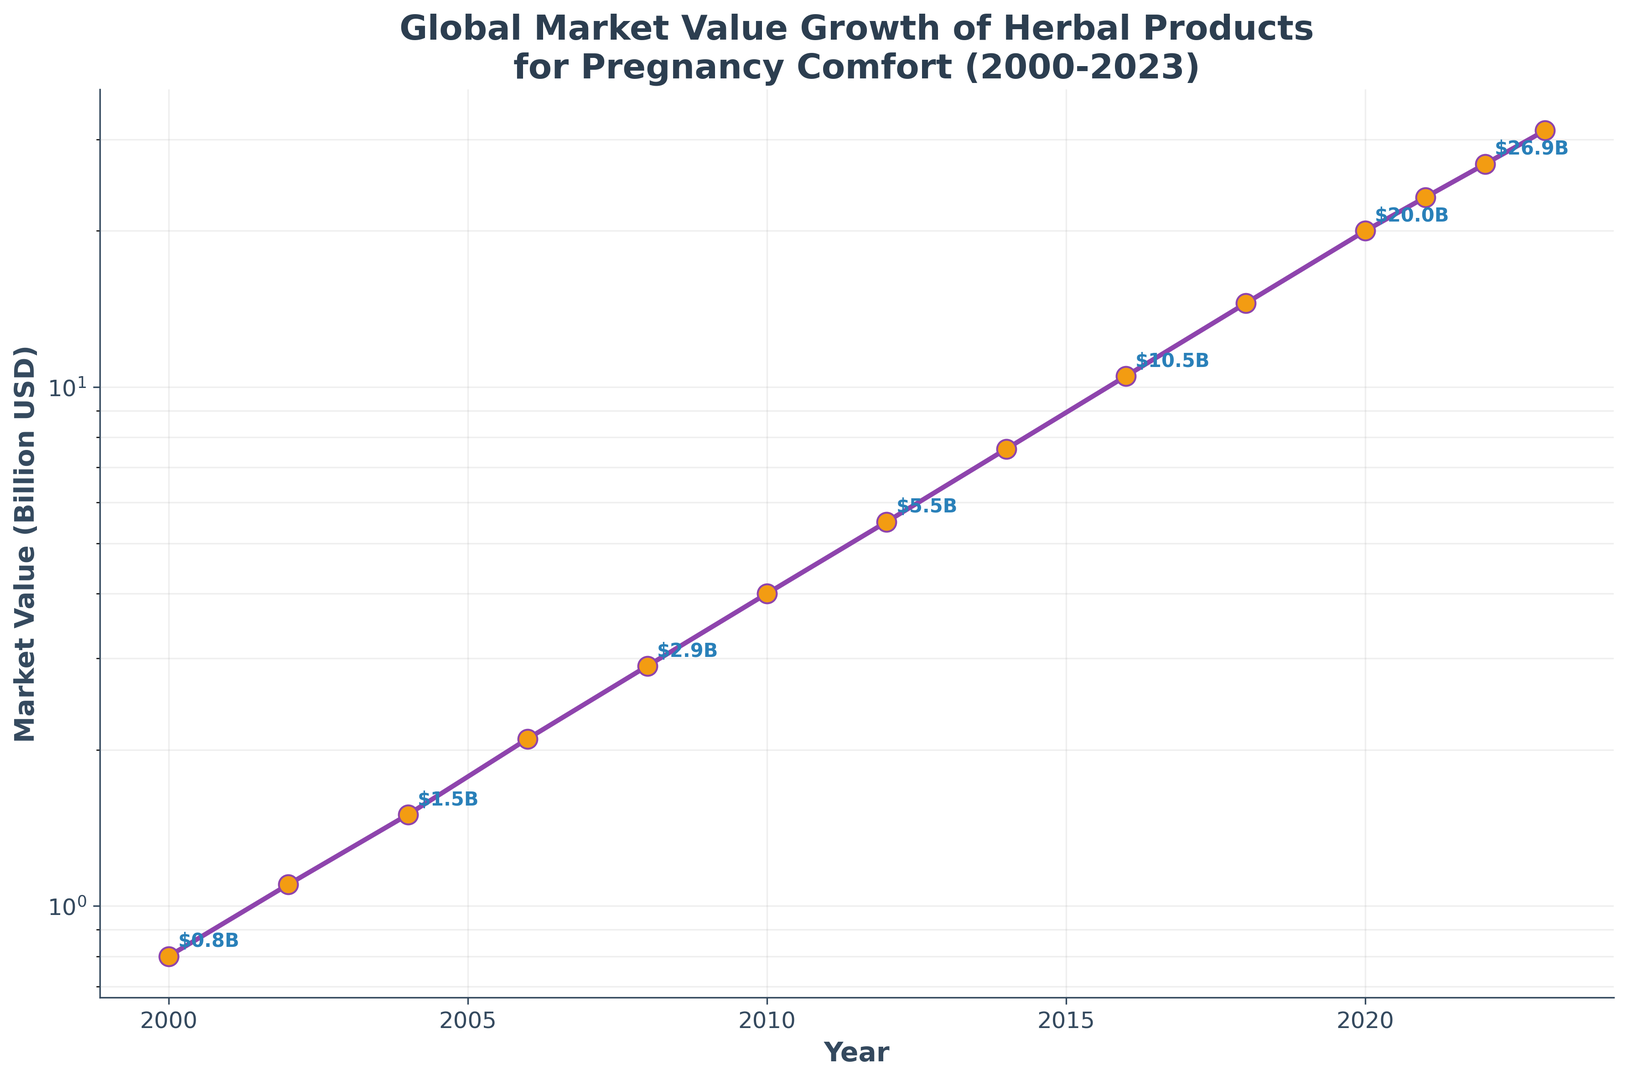What is the market value of herbal products for pregnancy comfort in 2010? In the figure, locate the year 2010 on the x-axis. Follow it up vertically to the y-axis to find the corresponding market value.
Answer: 4.0 billion USD How much did the market value increase from 2000 to 2006? Identify the market values for the years 2000 and 2006: 0.8 billion USD and 2.1 billion USD, respectively. Subtract the 2000 value from the 2006 value to find the increase: 2.1 - 0.8 = 1.3 billion USD.
Answer: 1.3 billion USD Between which two consecutive years did the market value see the largest increase? Review the intervals between each consecutive year and calculate the differences: 
- 2000-2002: 0.8 to 1.1 (+0.3)
- 2002-2004: 1.1 to 1.5 (+0.4)
- 2004-2006: 1.5 to 2.1 (+0.6)
- 2006-2008: 2.1 to 2.9 (+0.8)
- 2008-2010: 2.9 to 4.0 (+1.1)
- 2010-2012: 4.0 to 5.5 (+1.5)
- 2012-2014: 5.5 to 7.6 (+2.1)
- 2014-2016: 7.6 to 10.5 (+2.9)
- 2016-2018: 10.5 to 14.5 (+4.0)
- 2018-2020: 14.5 to 20.0 (+5.5)
- 2020-2021: 20.0 to 23.2 (+3.2)
- 2021-2022: 23.2 to 26.9 (+3.7)
- 2022-2023: 26.9 to 31.2 (+4.3) 
The largest increase is from 2018 to 2020.
Answer: 2018 to 2020 What is the average market value of herbal products for pregnancy comfort from 2010 to 2020? Identify the market values for the years 2010, 2012, 2014, 2016, 2018, and 2020: 4.0, 5.5, 7.6, 10.5, 14.5, and 20.0 billion USD. Sum these values and divide by the number of years to find the average: (4.0 + 5.5 + 7.6 + 10.5 + 14.5 + 20.0) / 6 = 62.1 / 6 = 10.35 billion USD
Answer: 10.35 billion USD By how many times did the global market value grow from 2000 to 2023? Identify the market values for the years 2000 and 2023: 0.8 billion USD and 31.2 billion USD. Divide the 2023 value by the 2000 value to find the growth factor: 31.2 / 0.8 = 39.
Answer: 39 times Which year had the first recorded market value above 10 billion USD? In the chart, scan the y-axis values and identify the first year that exceeded 10 billion USD. The year 2016 corresponds to a value of 10.5 billion USD.
Answer: 2016 Which years saw a market value doubling from the year immediately prior? Identify the years where the market value is at least twice that of the preceding year:
- 2010 (4.0) to 2012 (5.5) does not double.
- 2012 (5.5) to 2014 (7.6) does not double.
- 2014 (7.6) to 2016 (10.5) does not double.
- 2016 (10.5) to 2018 (14.5) does not double.
- 2018 (14.5) to 2020 (20.0) does not double.
None of the years recorded this doubling effect.
Answer: None 